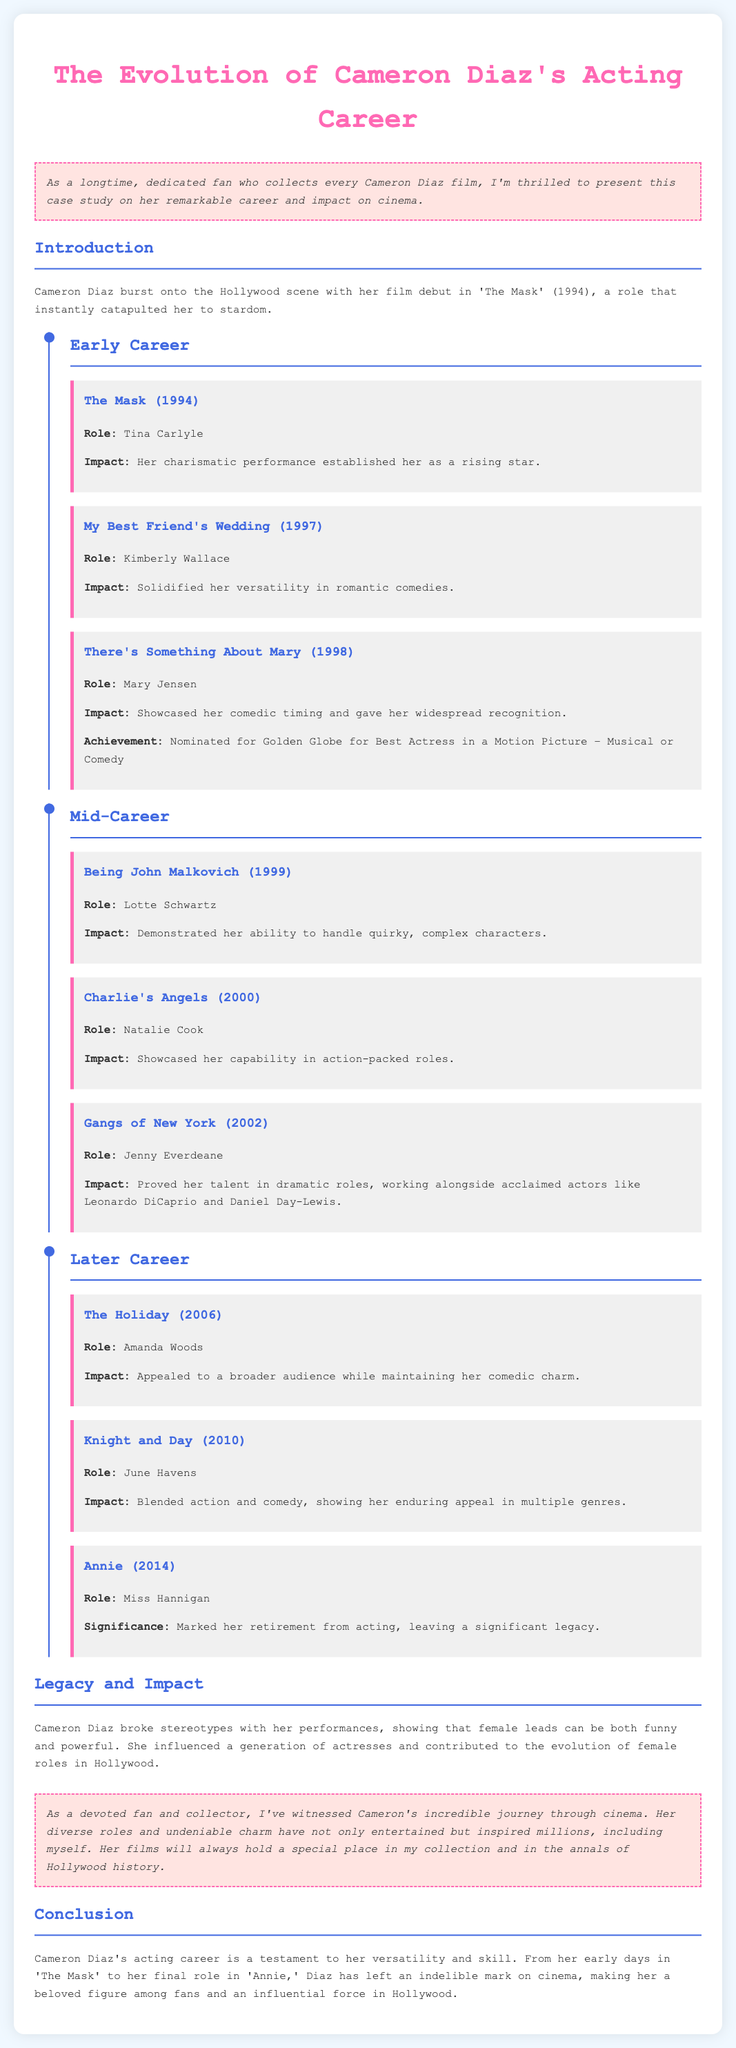What was Cameron Diaz's film debut? The document states that her film debut was 'The Mask' (1994).
Answer: 'The Mask' (1994) Which role did Cameron Diaz play in 'There's Something About Mary'? The document mentions that she played the role of Mary Jensen.
Answer: Mary Jensen In which year was 'My Best Friend's Wedding' released? The document indicates that 'My Best Friend's Wedding' was released in 1997.
Answer: 1997 How many movies are listed under the Mid-Career section? The document lists three films under the Mid-Career section.
Answer: 3 What did Cameron Diaz achieve with her role in 'There's Something About Mary'? The document states she was nominated for a Golden Globe for Best Actress in a Motion Picture – Musical or Comedy.
Answer: Nominated for Golden Globe What kind of roles does Cameron Diaz demonstrate versatility in? The document explains that she showed her versatility in romantic comedies.
Answer: Romantic comedies What was significant about her role in 'Annie'? The document notes that it marked her retirement from acting.
Answer: Retirement How did Cameron Diaz influence female roles in Hollywood? The document claims she broke stereotypes and influenced a generation of actresses.
Answer: Broke stereotypes What is the overall theme of Cameron Diaz's acting career as discussed in the case study? The document describes her career as a testament to her versatility and skill.
Answer: Versatility and skill 